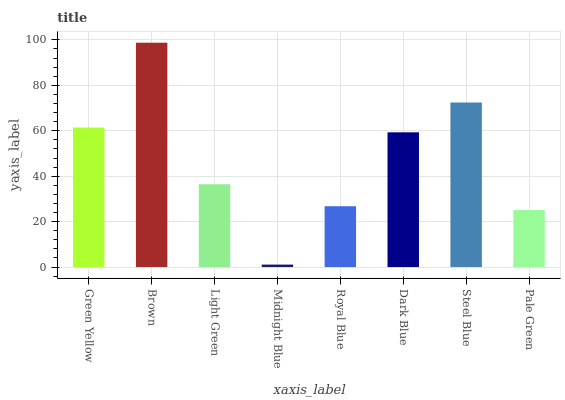Is Midnight Blue the minimum?
Answer yes or no. Yes. Is Brown the maximum?
Answer yes or no. Yes. Is Light Green the minimum?
Answer yes or no. No. Is Light Green the maximum?
Answer yes or no. No. Is Brown greater than Light Green?
Answer yes or no. Yes. Is Light Green less than Brown?
Answer yes or no. Yes. Is Light Green greater than Brown?
Answer yes or no. No. Is Brown less than Light Green?
Answer yes or no. No. Is Dark Blue the high median?
Answer yes or no. Yes. Is Light Green the low median?
Answer yes or no. Yes. Is Pale Green the high median?
Answer yes or no. No. Is Dark Blue the low median?
Answer yes or no. No. 